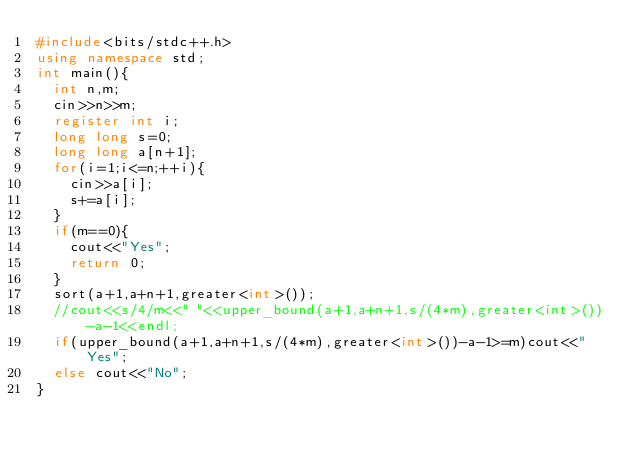Convert code to text. <code><loc_0><loc_0><loc_500><loc_500><_C++_>#include<bits/stdc++.h>
using namespace std;
int main(){
	int n,m;
	cin>>n>>m;
	register int i;
	long long s=0;
	long long a[n+1];
	for(i=1;i<=n;++i){
		cin>>a[i];
		s+=a[i];
	}
	if(m==0){
		cout<<"Yes";
		return 0;
	}
	sort(a+1,a+n+1,greater<int>());
	//cout<<s/4/m<<" "<<upper_bound(a+1,a+n+1,s/(4*m),greater<int>())-a-1<<endl;
	if(upper_bound(a+1,a+n+1,s/(4*m),greater<int>())-a-1>=m)cout<<"Yes";
	else cout<<"No";
}</code> 